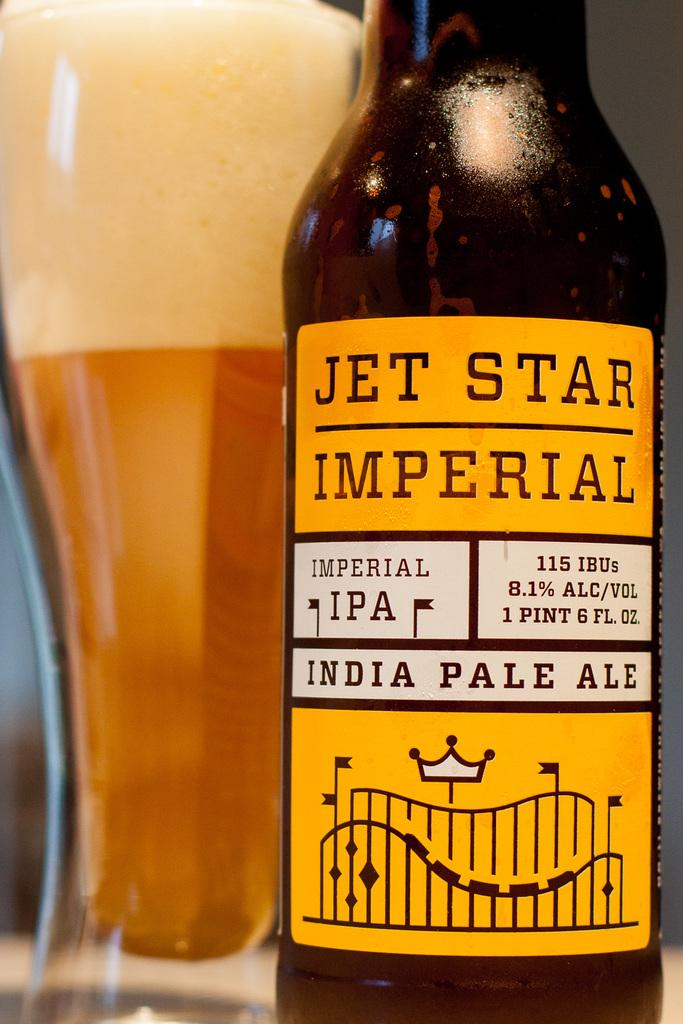What type of beverage is featured in the image? There is a wine bottle and a glass filled with wine in the image. Can you describe the glassware in the image? The glass is filled with wine, which is presumably from the wine bottle. What type of wound can be seen on the pancake in the image? There is no pancake present in the image, and therefore no wound can be observed. 